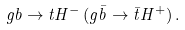<formula> <loc_0><loc_0><loc_500><loc_500>g b \to t H ^ { - } \, ( g \bar { b } \to \bar { t } H ^ { + } ) \, .</formula> 